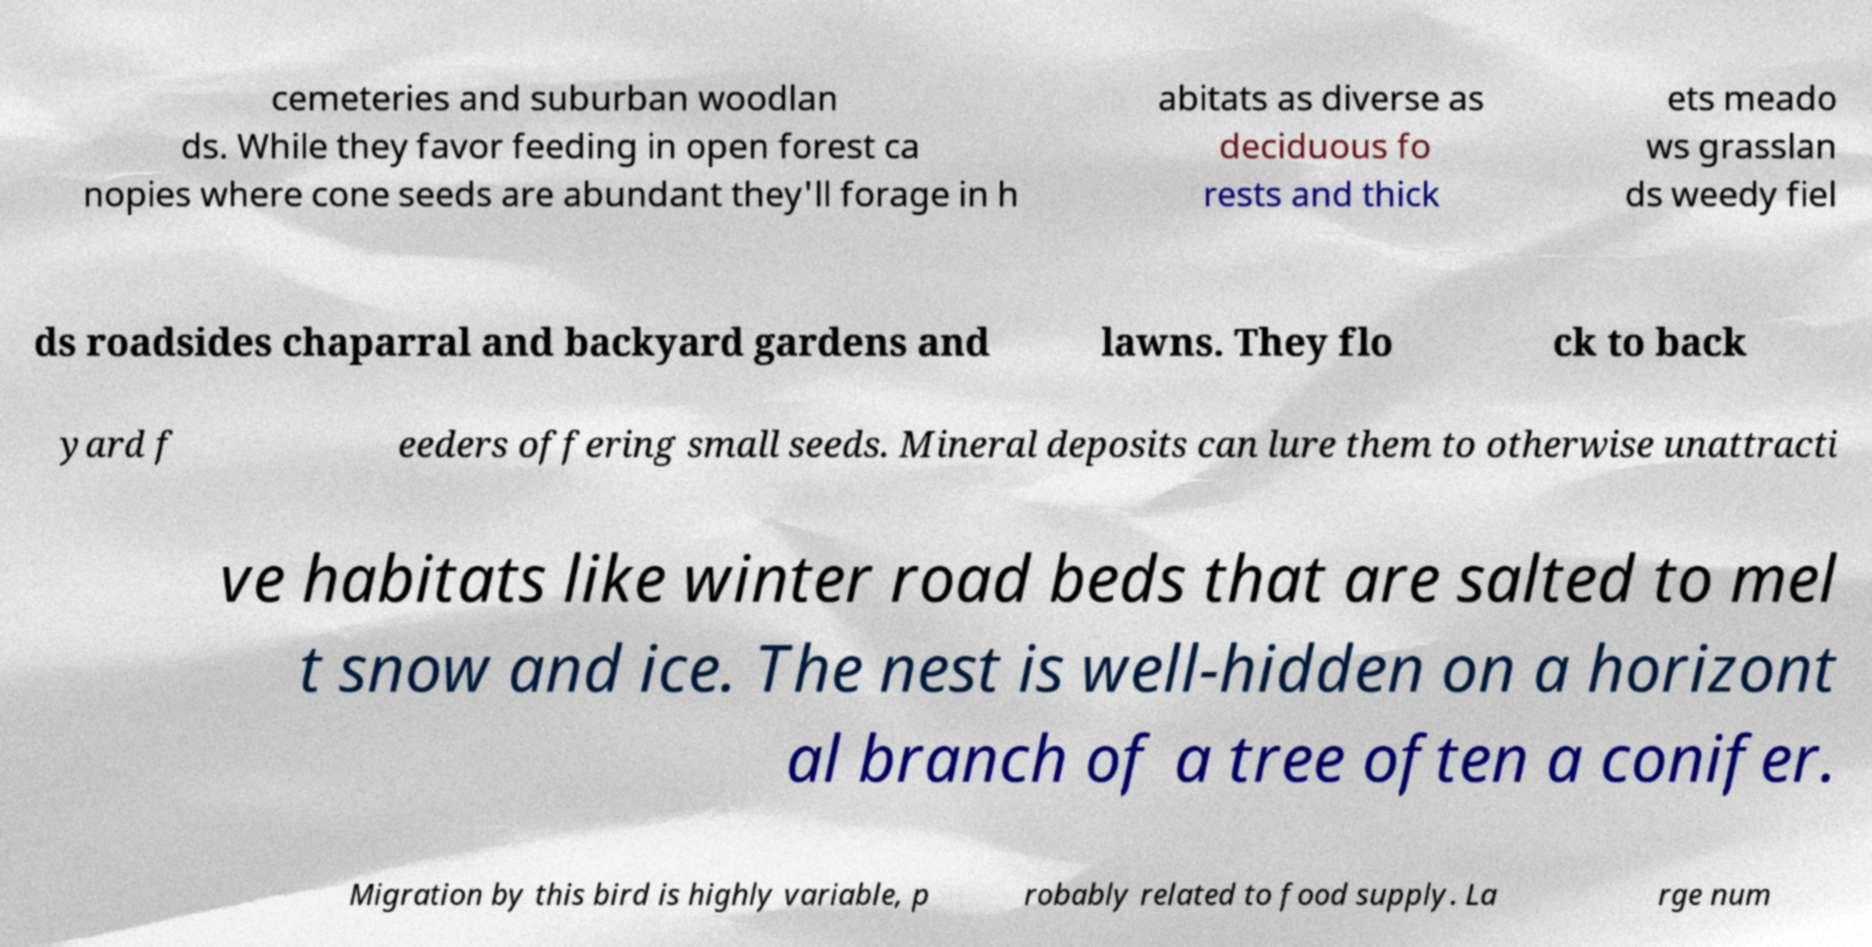Can you read and provide the text displayed in the image?This photo seems to have some interesting text. Can you extract and type it out for me? cemeteries and suburban woodlan ds. While they favor feeding in open forest ca nopies where cone seeds are abundant they'll forage in h abitats as diverse as deciduous fo rests and thick ets meado ws grasslan ds weedy fiel ds roadsides chaparral and backyard gardens and lawns. They flo ck to back yard f eeders offering small seeds. Mineral deposits can lure them to otherwise unattracti ve habitats like winter road beds that are salted to mel t snow and ice. The nest is well-hidden on a horizont al branch of a tree often a conifer. Migration by this bird is highly variable, p robably related to food supply. La rge num 